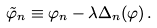<formula> <loc_0><loc_0><loc_500><loc_500>\tilde { \varphi } _ { n } \equiv \varphi _ { n } - \lambda \Delta _ { n } ( \varphi ) \, .</formula> 